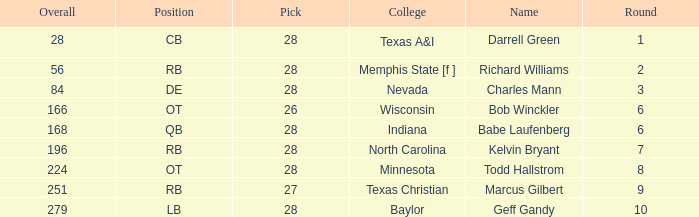What is the average round of the player from the college of baylor with a pick less than 28? None. 